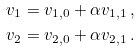Convert formula to latex. <formula><loc_0><loc_0><loc_500><loc_500>v _ { 1 } & = v _ { 1 , 0 } + \alpha v _ { 1 , 1 } \, , \\ v _ { 2 } & = v _ { 2 , 0 } + \alpha v _ { 2 , 1 } \, .</formula> 